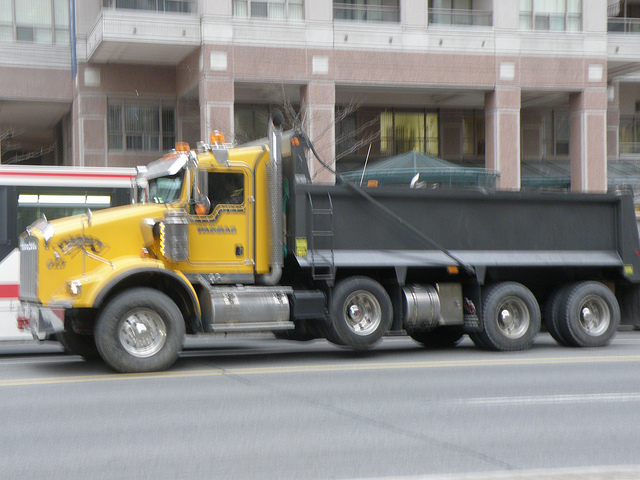<image>Who is driving the yellow truck? I'm not sure who is driving the yellow truck. It could be a man or a truck driver. Who is driving the yellow truck? I am not sure who is driving the yellow truck. It can be seen a truck driver or a man. 